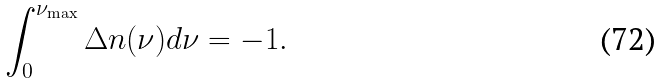Convert formula to latex. <formula><loc_0><loc_0><loc_500><loc_500>\int _ { 0 } ^ { \nu _ { \max } } \Delta n ( \nu ) d \nu = - 1 .</formula> 